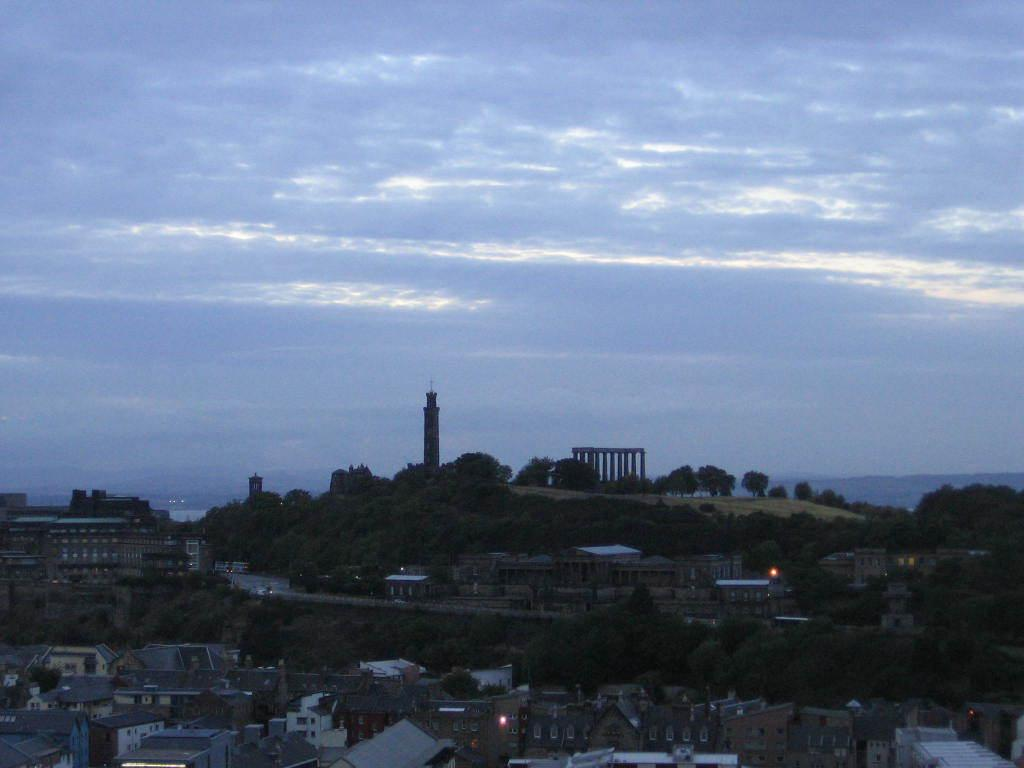What types of structures can be seen in the image? There are buildings, houses, a monument, and a tower in the image. What natural elements are present in the image? There are trees in the image. What man-made feature is visible in the image? There is a road in the image. What type of lighting is present in the image? There are lights in the image. What can be seen in the background of the image? The sky is visible in the background of the image, with clouds present. Is there a garden in the image where people can enjoy peace and quiet? There is no mention of a garden or any reference to peace and quiet in the image. 